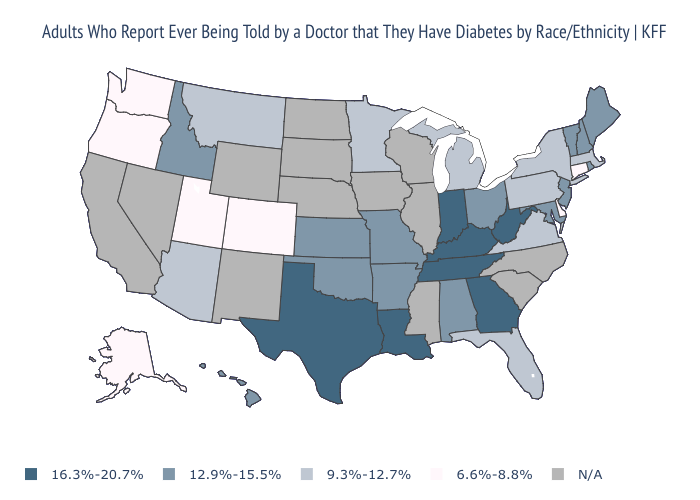What is the lowest value in states that border Pennsylvania?
Keep it brief. 6.6%-8.8%. Does New Hampshire have the lowest value in the Northeast?
Give a very brief answer. No. What is the value of Alabama?
Write a very short answer. 12.9%-15.5%. Does Oregon have the lowest value in the USA?
Concise answer only. Yes. Name the states that have a value in the range 9.3%-12.7%?
Answer briefly. Arizona, Florida, Massachusetts, Michigan, Minnesota, Montana, New York, Pennsylvania, Virginia. Name the states that have a value in the range 12.9%-15.5%?
Quick response, please. Alabama, Arkansas, Hawaii, Idaho, Kansas, Maine, Maryland, Missouri, New Hampshire, New Jersey, Ohio, Oklahoma, Rhode Island, Vermont. Which states have the highest value in the USA?
Keep it brief. Georgia, Indiana, Kentucky, Louisiana, Tennessee, Texas, West Virginia. Does Idaho have the highest value in the West?
Be succinct. Yes. Name the states that have a value in the range N/A?
Keep it brief. California, Illinois, Iowa, Mississippi, Nebraska, Nevada, New Mexico, North Carolina, North Dakota, South Carolina, South Dakota, Wisconsin, Wyoming. Which states hav the highest value in the West?
Short answer required. Hawaii, Idaho. What is the value of Illinois?
Short answer required. N/A. Which states have the lowest value in the MidWest?
Quick response, please. Michigan, Minnesota. 